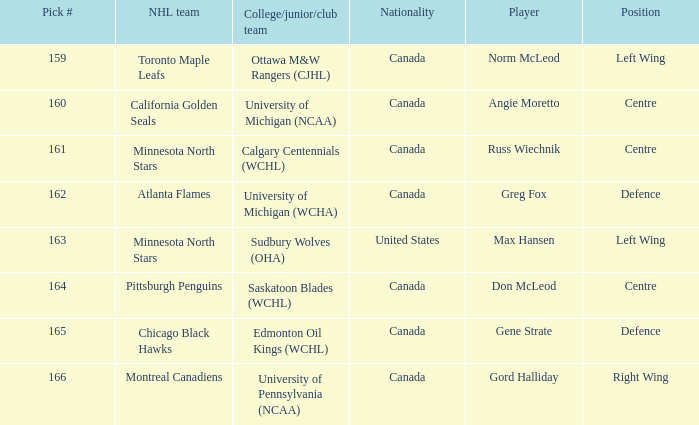Who came from the University of Michigan (NCAA) team? Angie Moretto. 